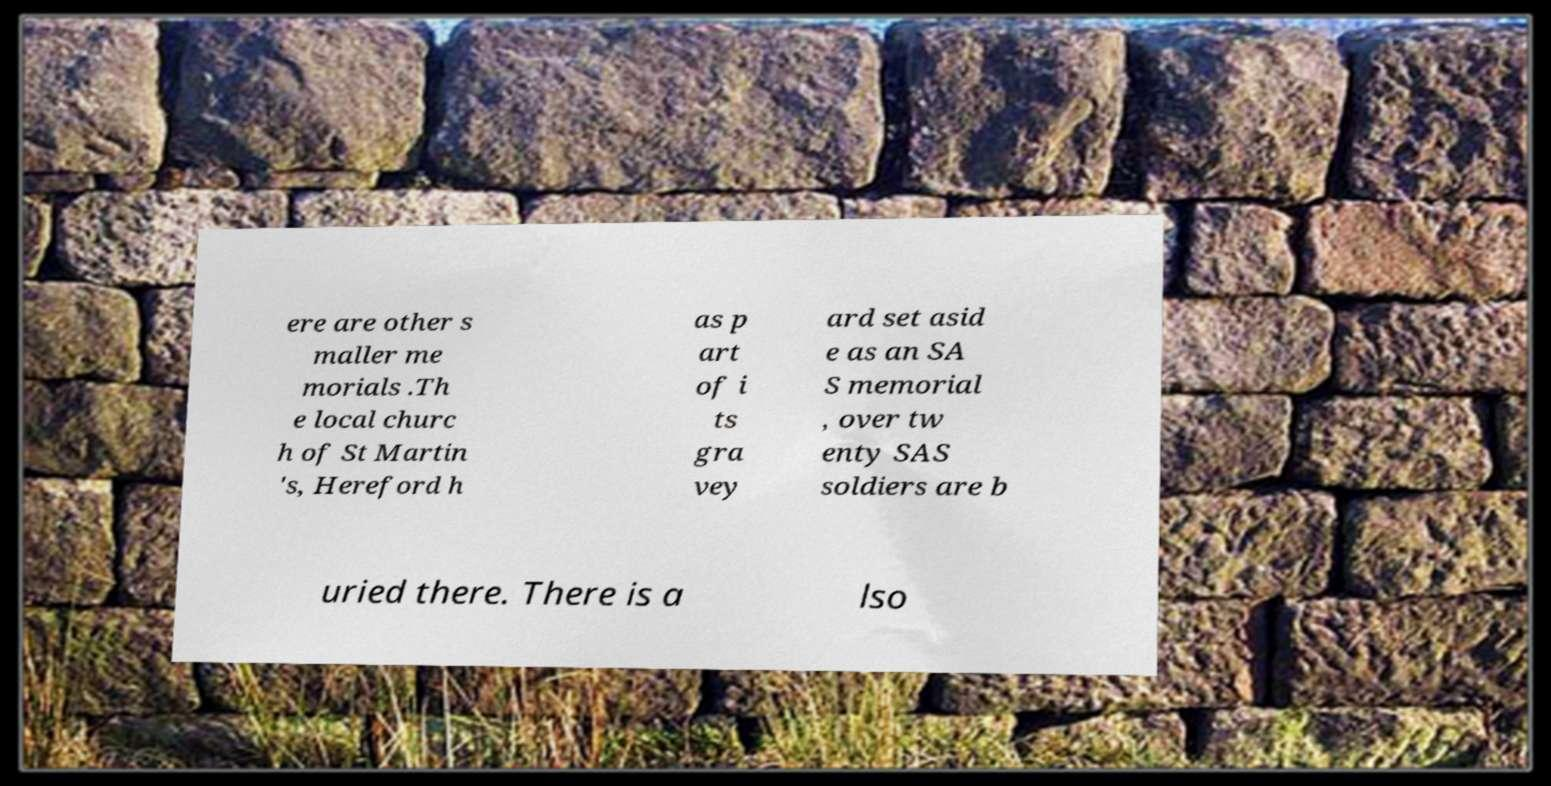What messages or text are displayed in this image? I need them in a readable, typed format. ere are other s maller me morials .Th e local churc h of St Martin 's, Hereford h as p art of i ts gra vey ard set asid e as an SA S memorial , over tw enty SAS soldiers are b uried there. There is a lso 